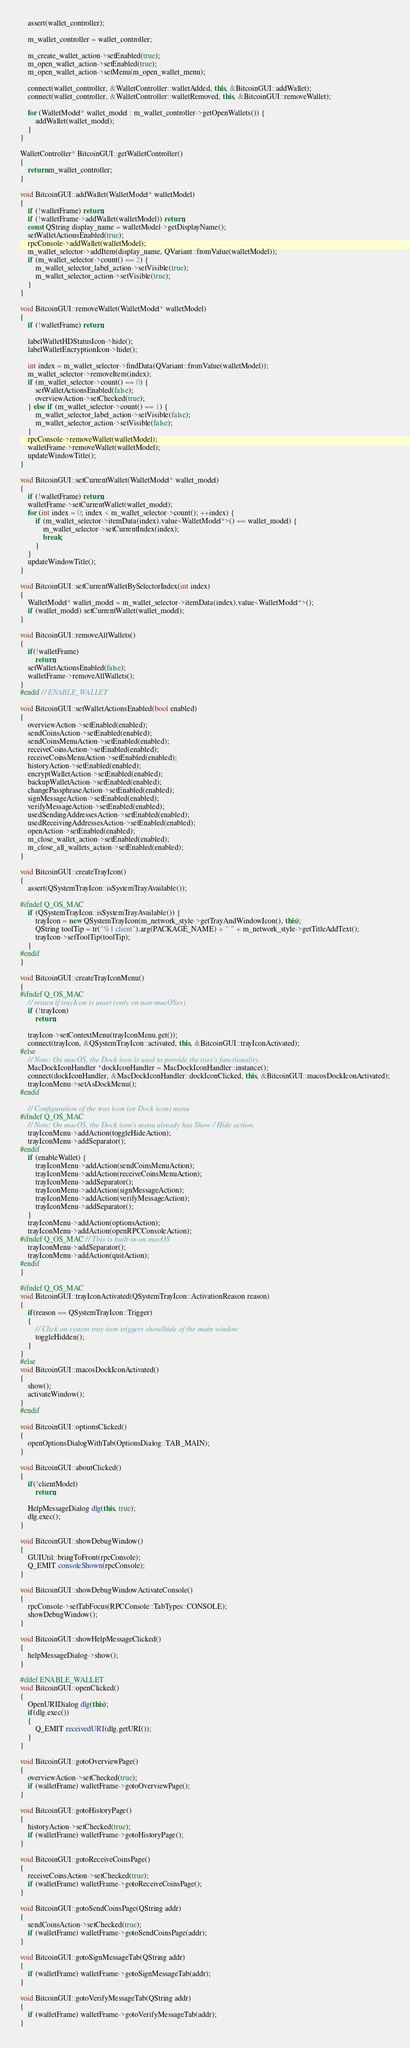<code> <loc_0><loc_0><loc_500><loc_500><_C++_>    assert(wallet_controller);

    m_wallet_controller = wallet_controller;

    m_create_wallet_action->setEnabled(true);
    m_open_wallet_action->setEnabled(true);
    m_open_wallet_action->setMenu(m_open_wallet_menu);

    connect(wallet_controller, &WalletController::walletAdded, this, &BitcoinGUI::addWallet);
    connect(wallet_controller, &WalletController::walletRemoved, this, &BitcoinGUI::removeWallet);

    for (WalletModel* wallet_model : m_wallet_controller->getOpenWallets()) {
        addWallet(wallet_model);
    }
}

WalletController* BitcoinGUI::getWalletController()
{
    return m_wallet_controller;
}

void BitcoinGUI::addWallet(WalletModel* walletModel)
{
    if (!walletFrame) return;
    if (!walletFrame->addWallet(walletModel)) return;
    const QString display_name = walletModel->getDisplayName();
    setWalletActionsEnabled(true);
    rpcConsole->addWallet(walletModel);
    m_wallet_selector->addItem(display_name, QVariant::fromValue(walletModel));
    if (m_wallet_selector->count() == 2) {
        m_wallet_selector_label_action->setVisible(true);
        m_wallet_selector_action->setVisible(true);
    }
}

void BitcoinGUI::removeWallet(WalletModel* walletModel)
{
    if (!walletFrame) return;

    labelWalletHDStatusIcon->hide();
    labelWalletEncryptionIcon->hide();

    int index = m_wallet_selector->findData(QVariant::fromValue(walletModel));
    m_wallet_selector->removeItem(index);
    if (m_wallet_selector->count() == 0) {
        setWalletActionsEnabled(false);
        overviewAction->setChecked(true);
    } else if (m_wallet_selector->count() == 1) {
        m_wallet_selector_label_action->setVisible(false);
        m_wallet_selector_action->setVisible(false);
    }
    rpcConsole->removeWallet(walletModel);
    walletFrame->removeWallet(walletModel);
    updateWindowTitle();
}

void BitcoinGUI::setCurrentWallet(WalletModel* wallet_model)
{
    if (!walletFrame) return;
    walletFrame->setCurrentWallet(wallet_model);
    for (int index = 0; index < m_wallet_selector->count(); ++index) {
        if (m_wallet_selector->itemData(index).value<WalletModel*>() == wallet_model) {
            m_wallet_selector->setCurrentIndex(index);
            break;
        }
    }
    updateWindowTitle();
}

void BitcoinGUI::setCurrentWalletBySelectorIndex(int index)
{
    WalletModel* wallet_model = m_wallet_selector->itemData(index).value<WalletModel*>();
    if (wallet_model) setCurrentWallet(wallet_model);
}

void BitcoinGUI::removeAllWallets()
{
    if(!walletFrame)
        return;
    setWalletActionsEnabled(false);
    walletFrame->removeAllWallets();
}
#endif // ENABLE_WALLET

void BitcoinGUI::setWalletActionsEnabled(bool enabled)
{
    overviewAction->setEnabled(enabled);
    sendCoinsAction->setEnabled(enabled);
    sendCoinsMenuAction->setEnabled(enabled);
    receiveCoinsAction->setEnabled(enabled);
    receiveCoinsMenuAction->setEnabled(enabled);
    historyAction->setEnabled(enabled);
    encryptWalletAction->setEnabled(enabled);
    backupWalletAction->setEnabled(enabled);
    changePassphraseAction->setEnabled(enabled);
    signMessageAction->setEnabled(enabled);
    verifyMessageAction->setEnabled(enabled);
    usedSendingAddressesAction->setEnabled(enabled);
    usedReceivingAddressesAction->setEnabled(enabled);
    openAction->setEnabled(enabled);
    m_close_wallet_action->setEnabled(enabled);
    m_close_all_wallets_action->setEnabled(enabled);
}

void BitcoinGUI::createTrayIcon()
{
    assert(QSystemTrayIcon::isSystemTrayAvailable());

#ifndef Q_OS_MAC
    if (QSystemTrayIcon::isSystemTrayAvailable()) {
        trayIcon = new QSystemTrayIcon(m_network_style->getTrayAndWindowIcon(), this);
        QString toolTip = tr("%1 client").arg(PACKAGE_NAME) + " " + m_network_style->getTitleAddText();
        trayIcon->setToolTip(toolTip);
    }
#endif
}

void BitcoinGUI::createTrayIconMenu()
{
#ifndef Q_OS_MAC
    // return if trayIcon is unset (only on non-macOSes)
    if (!trayIcon)
        return;

    trayIcon->setContextMenu(trayIconMenu.get());
    connect(trayIcon, &QSystemTrayIcon::activated, this, &BitcoinGUI::trayIconActivated);
#else
    // Note: On macOS, the Dock icon is used to provide the tray's functionality.
    MacDockIconHandler *dockIconHandler = MacDockIconHandler::instance();
    connect(dockIconHandler, &MacDockIconHandler::dockIconClicked, this, &BitcoinGUI::macosDockIconActivated);
    trayIconMenu->setAsDockMenu();
#endif

    // Configuration of the tray icon (or Dock icon) menu
#ifndef Q_OS_MAC
    // Note: On macOS, the Dock icon's menu already has Show / Hide action.
    trayIconMenu->addAction(toggleHideAction);
    trayIconMenu->addSeparator();
#endif
    if (enableWallet) {
        trayIconMenu->addAction(sendCoinsMenuAction);
        trayIconMenu->addAction(receiveCoinsMenuAction);
        trayIconMenu->addSeparator();
        trayIconMenu->addAction(signMessageAction);
        trayIconMenu->addAction(verifyMessageAction);
        trayIconMenu->addSeparator();
    }
    trayIconMenu->addAction(optionsAction);
    trayIconMenu->addAction(openRPCConsoleAction);
#ifndef Q_OS_MAC // This is built-in on macOS
    trayIconMenu->addSeparator();
    trayIconMenu->addAction(quitAction);
#endif
}

#ifndef Q_OS_MAC
void BitcoinGUI::trayIconActivated(QSystemTrayIcon::ActivationReason reason)
{
    if(reason == QSystemTrayIcon::Trigger)
    {
        // Click on system tray icon triggers show/hide of the main window
        toggleHidden();
    }
}
#else
void BitcoinGUI::macosDockIconActivated()
{
    show();
    activateWindow();
}
#endif

void BitcoinGUI::optionsClicked()
{
    openOptionsDialogWithTab(OptionsDialog::TAB_MAIN);
}

void BitcoinGUI::aboutClicked()
{
    if(!clientModel)
        return;

    HelpMessageDialog dlg(this, true);
    dlg.exec();
}

void BitcoinGUI::showDebugWindow()
{
    GUIUtil::bringToFront(rpcConsole);
    Q_EMIT consoleShown(rpcConsole);
}

void BitcoinGUI::showDebugWindowActivateConsole()
{
    rpcConsole->setTabFocus(RPCConsole::TabTypes::CONSOLE);
    showDebugWindow();
}

void BitcoinGUI::showHelpMessageClicked()
{
    helpMessageDialog->show();
}

#ifdef ENABLE_WALLET
void BitcoinGUI::openClicked()
{
    OpenURIDialog dlg(this);
    if(dlg.exec())
    {
        Q_EMIT receivedURI(dlg.getURI());
    }
}

void BitcoinGUI::gotoOverviewPage()
{
    overviewAction->setChecked(true);
    if (walletFrame) walletFrame->gotoOverviewPage();
}

void BitcoinGUI::gotoHistoryPage()
{
    historyAction->setChecked(true);
    if (walletFrame) walletFrame->gotoHistoryPage();
}

void BitcoinGUI::gotoReceiveCoinsPage()
{
    receiveCoinsAction->setChecked(true);
    if (walletFrame) walletFrame->gotoReceiveCoinsPage();
}

void BitcoinGUI::gotoSendCoinsPage(QString addr)
{
    sendCoinsAction->setChecked(true);
    if (walletFrame) walletFrame->gotoSendCoinsPage(addr);
}

void BitcoinGUI::gotoSignMessageTab(QString addr)
{
    if (walletFrame) walletFrame->gotoSignMessageTab(addr);
}

void BitcoinGUI::gotoVerifyMessageTab(QString addr)
{
    if (walletFrame) walletFrame->gotoVerifyMessageTab(addr);
}</code> 